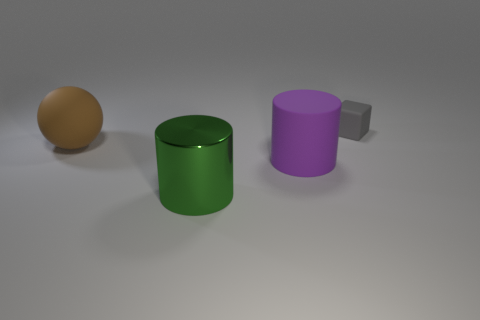There is another purple thing that is the same shape as the shiny thing; what is it made of?
Provide a short and direct response. Rubber. How many yellow things are rubber objects or big rubber cylinders?
Offer a very short reply. 0. Are there any other things of the same color as the matte sphere?
Offer a very short reply. No. What color is the big cylinder in front of the large rubber object that is in front of the large brown matte thing?
Ensure brevity in your answer.  Green. Is the number of green metal objects that are in front of the large green object less than the number of green cylinders that are behind the gray rubber cube?
Keep it short and to the point. No. How many objects are either objects on the left side of the tiny gray rubber block or large spheres?
Provide a succinct answer. 3. There is a thing behind the brown sphere; is its size the same as the brown matte ball?
Provide a short and direct response. No. Are there fewer green metallic cylinders that are to the left of the purple rubber cylinder than green balls?
Keep it short and to the point. No. There is a brown sphere that is the same size as the green metallic object; what is its material?
Offer a terse response. Rubber. How many large objects are purple rubber cylinders or green metal things?
Provide a short and direct response. 2. 